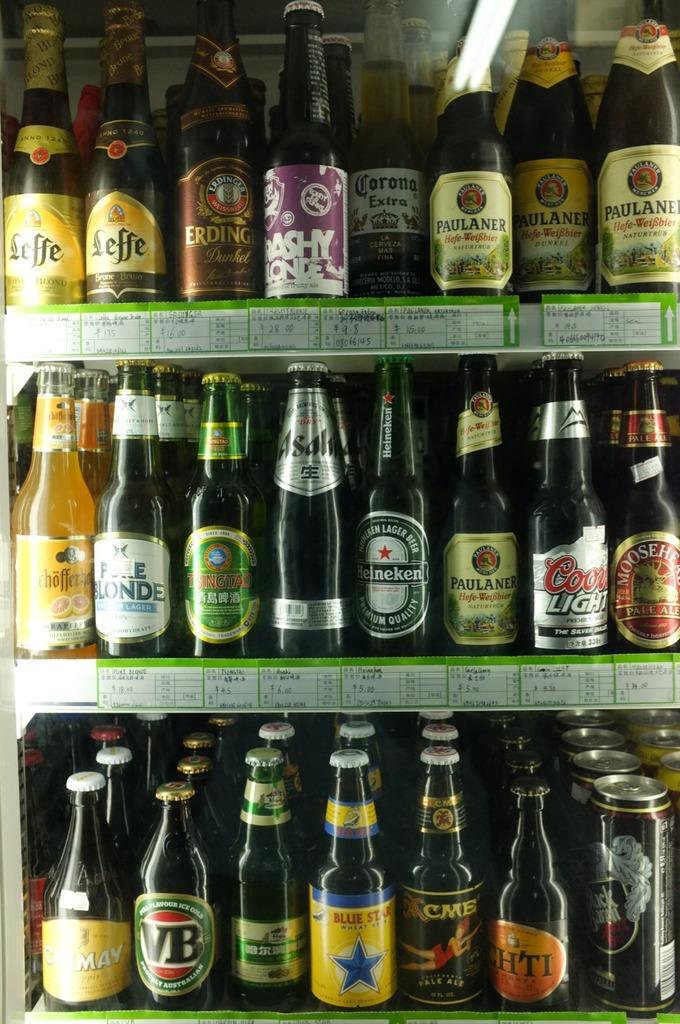What is the name on one of the bottles?
Provide a short and direct response. Coors light. What is the bottle second from right on the middle shelf say?
Give a very brief answer. Coors light. 